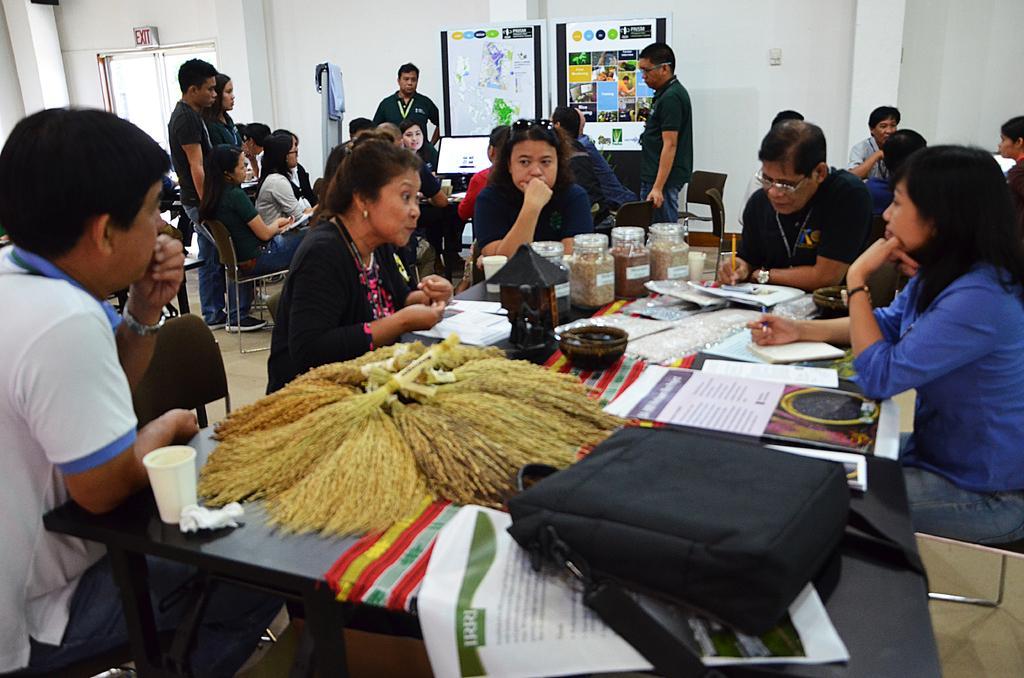Can you describe this image briefly? In this image there are a few people sitting, in between them there is a table with books, papers, bottles and other objects on it, behind them there are a few more people sitting and standing, in front of them there is a monitor. In the background there are a few posters with some images and text are hanging on the wall. On the left side of the image there is a door. 